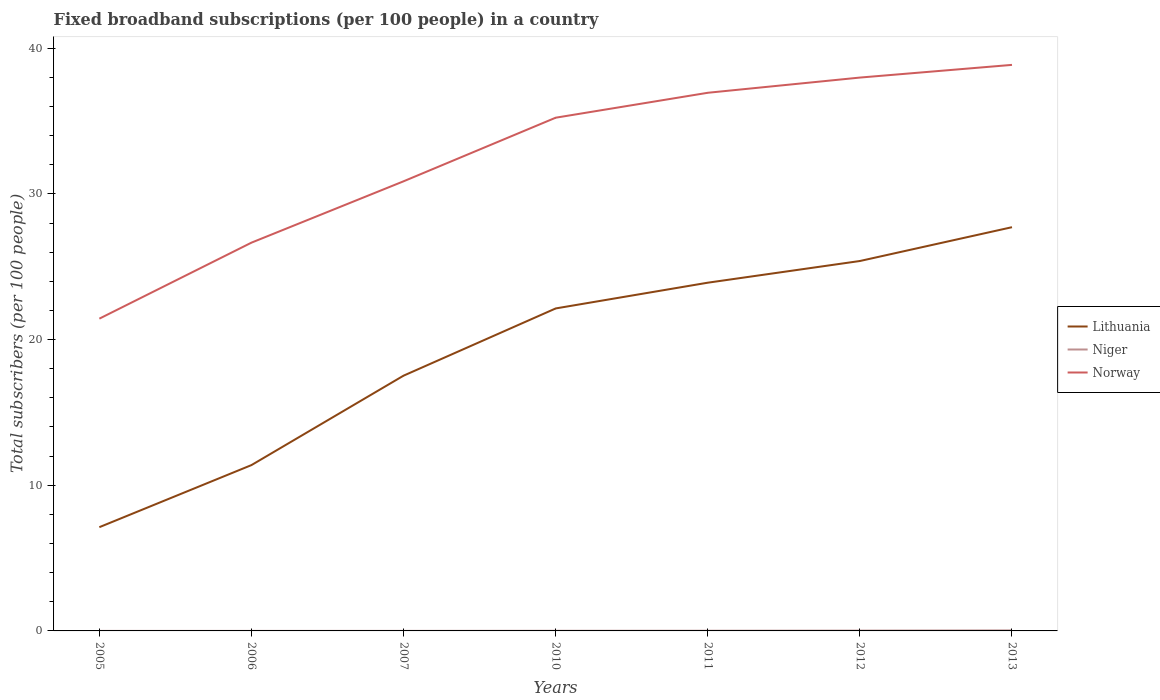Is the number of lines equal to the number of legend labels?
Your response must be concise. Yes. Across all years, what is the maximum number of broadband subscriptions in Niger?
Your response must be concise. 0. What is the total number of broadband subscriptions in Niger in the graph?
Provide a succinct answer. -0.01. What is the difference between the highest and the second highest number of broadband subscriptions in Niger?
Your answer should be very brief. 0.03. How many legend labels are there?
Provide a succinct answer. 3. What is the title of the graph?
Provide a succinct answer. Fixed broadband subscriptions (per 100 people) in a country. Does "Panama" appear as one of the legend labels in the graph?
Make the answer very short. No. What is the label or title of the Y-axis?
Keep it short and to the point. Total subscribers (per 100 people). What is the Total subscribers (per 100 people) of Lithuania in 2005?
Keep it short and to the point. 7.12. What is the Total subscribers (per 100 people) of Niger in 2005?
Offer a terse response. 0. What is the Total subscribers (per 100 people) of Norway in 2005?
Your answer should be very brief. 21.44. What is the Total subscribers (per 100 people) in Lithuania in 2006?
Your answer should be compact. 11.38. What is the Total subscribers (per 100 people) in Niger in 2006?
Your answer should be very brief. 0. What is the Total subscribers (per 100 people) in Norway in 2006?
Offer a terse response. 26.66. What is the Total subscribers (per 100 people) of Lithuania in 2007?
Offer a terse response. 17.52. What is the Total subscribers (per 100 people) in Niger in 2007?
Provide a short and direct response. 0. What is the Total subscribers (per 100 people) of Norway in 2007?
Ensure brevity in your answer.  30.87. What is the Total subscribers (per 100 people) in Lithuania in 2010?
Ensure brevity in your answer.  22.14. What is the Total subscribers (per 100 people) of Niger in 2010?
Offer a very short reply. 0.01. What is the Total subscribers (per 100 people) in Norway in 2010?
Your answer should be compact. 35.23. What is the Total subscribers (per 100 people) of Lithuania in 2011?
Your answer should be very brief. 23.91. What is the Total subscribers (per 100 people) in Niger in 2011?
Offer a terse response. 0.01. What is the Total subscribers (per 100 people) of Norway in 2011?
Your answer should be compact. 36.94. What is the Total subscribers (per 100 people) in Lithuania in 2012?
Provide a succinct answer. 25.39. What is the Total subscribers (per 100 people) of Niger in 2012?
Your response must be concise. 0.02. What is the Total subscribers (per 100 people) in Norway in 2012?
Give a very brief answer. 37.99. What is the Total subscribers (per 100 people) of Lithuania in 2013?
Your response must be concise. 27.72. What is the Total subscribers (per 100 people) in Niger in 2013?
Keep it short and to the point. 0.04. What is the Total subscribers (per 100 people) in Norway in 2013?
Your answer should be very brief. 38.86. Across all years, what is the maximum Total subscribers (per 100 people) of Lithuania?
Make the answer very short. 27.72. Across all years, what is the maximum Total subscribers (per 100 people) in Niger?
Provide a succinct answer. 0.04. Across all years, what is the maximum Total subscribers (per 100 people) of Norway?
Provide a short and direct response. 38.86. Across all years, what is the minimum Total subscribers (per 100 people) of Lithuania?
Keep it short and to the point. 7.12. Across all years, what is the minimum Total subscribers (per 100 people) of Niger?
Your answer should be very brief. 0. Across all years, what is the minimum Total subscribers (per 100 people) of Norway?
Provide a short and direct response. 21.44. What is the total Total subscribers (per 100 people) in Lithuania in the graph?
Ensure brevity in your answer.  135.19. What is the total Total subscribers (per 100 people) of Niger in the graph?
Your answer should be compact. 0.09. What is the total Total subscribers (per 100 people) in Norway in the graph?
Keep it short and to the point. 227.99. What is the difference between the Total subscribers (per 100 people) of Lithuania in 2005 and that in 2006?
Make the answer very short. -4.26. What is the difference between the Total subscribers (per 100 people) in Niger in 2005 and that in 2006?
Your answer should be very brief. -0. What is the difference between the Total subscribers (per 100 people) in Norway in 2005 and that in 2006?
Ensure brevity in your answer.  -5.22. What is the difference between the Total subscribers (per 100 people) of Lithuania in 2005 and that in 2007?
Give a very brief answer. -10.4. What is the difference between the Total subscribers (per 100 people) of Niger in 2005 and that in 2007?
Ensure brevity in your answer.  -0. What is the difference between the Total subscribers (per 100 people) of Norway in 2005 and that in 2007?
Make the answer very short. -9.43. What is the difference between the Total subscribers (per 100 people) of Lithuania in 2005 and that in 2010?
Give a very brief answer. -15.02. What is the difference between the Total subscribers (per 100 people) in Niger in 2005 and that in 2010?
Offer a very short reply. -0.01. What is the difference between the Total subscribers (per 100 people) of Norway in 2005 and that in 2010?
Your answer should be very brief. -13.8. What is the difference between the Total subscribers (per 100 people) in Lithuania in 2005 and that in 2011?
Provide a short and direct response. -16.78. What is the difference between the Total subscribers (per 100 people) in Niger in 2005 and that in 2011?
Your answer should be compact. -0.01. What is the difference between the Total subscribers (per 100 people) in Norway in 2005 and that in 2011?
Offer a terse response. -15.51. What is the difference between the Total subscribers (per 100 people) of Lithuania in 2005 and that in 2012?
Provide a succinct answer. -18.27. What is the difference between the Total subscribers (per 100 people) of Niger in 2005 and that in 2012?
Your answer should be compact. -0.02. What is the difference between the Total subscribers (per 100 people) of Norway in 2005 and that in 2012?
Ensure brevity in your answer.  -16.55. What is the difference between the Total subscribers (per 100 people) in Lithuania in 2005 and that in 2013?
Provide a succinct answer. -20.59. What is the difference between the Total subscribers (per 100 people) in Niger in 2005 and that in 2013?
Make the answer very short. -0.03. What is the difference between the Total subscribers (per 100 people) of Norway in 2005 and that in 2013?
Provide a succinct answer. -17.42. What is the difference between the Total subscribers (per 100 people) in Lithuania in 2006 and that in 2007?
Give a very brief answer. -6.14. What is the difference between the Total subscribers (per 100 people) of Niger in 2006 and that in 2007?
Provide a short and direct response. -0. What is the difference between the Total subscribers (per 100 people) of Norway in 2006 and that in 2007?
Give a very brief answer. -4.21. What is the difference between the Total subscribers (per 100 people) in Lithuania in 2006 and that in 2010?
Give a very brief answer. -10.75. What is the difference between the Total subscribers (per 100 people) in Niger in 2006 and that in 2010?
Offer a terse response. -0.01. What is the difference between the Total subscribers (per 100 people) of Norway in 2006 and that in 2010?
Your answer should be very brief. -8.58. What is the difference between the Total subscribers (per 100 people) of Lithuania in 2006 and that in 2011?
Provide a succinct answer. -12.52. What is the difference between the Total subscribers (per 100 people) in Niger in 2006 and that in 2011?
Your answer should be compact. -0.01. What is the difference between the Total subscribers (per 100 people) of Norway in 2006 and that in 2011?
Provide a short and direct response. -10.29. What is the difference between the Total subscribers (per 100 people) in Lithuania in 2006 and that in 2012?
Give a very brief answer. -14.01. What is the difference between the Total subscribers (per 100 people) in Niger in 2006 and that in 2012?
Keep it short and to the point. -0.02. What is the difference between the Total subscribers (per 100 people) of Norway in 2006 and that in 2012?
Provide a short and direct response. -11.33. What is the difference between the Total subscribers (per 100 people) of Lithuania in 2006 and that in 2013?
Your response must be concise. -16.33. What is the difference between the Total subscribers (per 100 people) in Niger in 2006 and that in 2013?
Provide a short and direct response. -0.03. What is the difference between the Total subscribers (per 100 people) in Norway in 2006 and that in 2013?
Your answer should be very brief. -12.2. What is the difference between the Total subscribers (per 100 people) in Lithuania in 2007 and that in 2010?
Provide a short and direct response. -4.61. What is the difference between the Total subscribers (per 100 people) in Niger in 2007 and that in 2010?
Provide a succinct answer. -0.01. What is the difference between the Total subscribers (per 100 people) of Norway in 2007 and that in 2010?
Ensure brevity in your answer.  -4.37. What is the difference between the Total subscribers (per 100 people) of Lithuania in 2007 and that in 2011?
Provide a short and direct response. -6.38. What is the difference between the Total subscribers (per 100 people) of Niger in 2007 and that in 2011?
Make the answer very short. -0.01. What is the difference between the Total subscribers (per 100 people) of Norway in 2007 and that in 2011?
Offer a terse response. -6.08. What is the difference between the Total subscribers (per 100 people) in Lithuania in 2007 and that in 2012?
Make the answer very short. -7.87. What is the difference between the Total subscribers (per 100 people) in Niger in 2007 and that in 2012?
Provide a succinct answer. -0.02. What is the difference between the Total subscribers (per 100 people) in Norway in 2007 and that in 2012?
Offer a very short reply. -7.12. What is the difference between the Total subscribers (per 100 people) in Lithuania in 2007 and that in 2013?
Keep it short and to the point. -10.19. What is the difference between the Total subscribers (per 100 people) in Niger in 2007 and that in 2013?
Your answer should be compact. -0.03. What is the difference between the Total subscribers (per 100 people) of Norway in 2007 and that in 2013?
Ensure brevity in your answer.  -7.99. What is the difference between the Total subscribers (per 100 people) of Lithuania in 2010 and that in 2011?
Keep it short and to the point. -1.77. What is the difference between the Total subscribers (per 100 people) in Niger in 2010 and that in 2011?
Keep it short and to the point. -0. What is the difference between the Total subscribers (per 100 people) in Norway in 2010 and that in 2011?
Your answer should be very brief. -1.71. What is the difference between the Total subscribers (per 100 people) in Lithuania in 2010 and that in 2012?
Offer a terse response. -3.26. What is the difference between the Total subscribers (per 100 people) in Niger in 2010 and that in 2012?
Keep it short and to the point. -0.01. What is the difference between the Total subscribers (per 100 people) in Norway in 2010 and that in 2012?
Provide a short and direct response. -2.75. What is the difference between the Total subscribers (per 100 people) in Lithuania in 2010 and that in 2013?
Your answer should be compact. -5.58. What is the difference between the Total subscribers (per 100 people) of Niger in 2010 and that in 2013?
Offer a very short reply. -0.03. What is the difference between the Total subscribers (per 100 people) of Norway in 2010 and that in 2013?
Your answer should be compact. -3.63. What is the difference between the Total subscribers (per 100 people) in Lithuania in 2011 and that in 2012?
Your response must be concise. -1.49. What is the difference between the Total subscribers (per 100 people) in Niger in 2011 and that in 2012?
Offer a very short reply. -0.01. What is the difference between the Total subscribers (per 100 people) of Norway in 2011 and that in 2012?
Your response must be concise. -1.04. What is the difference between the Total subscribers (per 100 people) of Lithuania in 2011 and that in 2013?
Provide a succinct answer. -3.81. What is the difference between the Total subscribers (per 100 people) in Niger in 2011 and that in 2013?
Your answer should be compact. -0.02. What is the difference between the Total subscribers (per 100 people) in Norway in 2011 and that in 2013?
Offer a terse response. -1.92. What is the difference between the Total subscribers (per 100 people) of Lithuania in 2012 and that in 2013?
Your answer should be very brief. -2.32. What is the difference between the Total subscribers (per 100 people) in Niger in 2012 and that in 2013?
Provide a short and direct response. -0.01. What is the difference between the Total subscribers (per 100 people) of Norway in 2012 and that in 2013?
Give a very brief answer. -0.87. What is the difference between the Total subscribers (per 100 people) in Lithuania in 2005 and the Total subscribers (per 100 people) in Niger in 2006?
Your answer should be very brief. 7.12. What is the difference between the Total subscribers (per 100 people) of Lithuania in 2005 and the Total subscribers (per 100 people) of Norway in 2006?
Provide a short and direct response. -19.53. What is the difference between the Total subscribers (per 100 people) in Niger in 2005 and the Total subscribers (per 100 people) in Norway in 2006?
Ensure brevity in your answer.  -26.65. What is the difference between the Total subscribers (per 100 people) of Lithuania in 2005 and the Total subscribers (per 100 people) of Niger in 2007?
Offer a terse response. 7.12. What is the difference between the Total subscribers (per 100 people) of Lithuania in 2005 and the Total subscribers (per 100 people) of Norway in 2007?
Offer a very short reply. -23.75. What is the difference between the Total subscribers (per 100 people) of Niger in 2005 and the Total subscribers (per 100 people) of Norway in 2007?
Provide a succinct answer. -30.87. What is the difference between the Total subscribers (per 100 people) of Lithuania in 2005 and the Total subscribers (per 100 people) of Niger in 2010?
Offer a very short reply. 7.11. What is the difference between the Total subscribers (per 100 people) in Lithuania in 2005 and the Total subscribers (per 100 people) in Norway in 2010?
Give a very brief answer. -28.11. What is the difference between the Total subscribers (per 100 people) in Niger in 2005 and the Total subscribers (per 100 people) in Norway in 2010?
Make the answer very short. -35.23. What is the difference between the Total subscribers (per 100 people) in Lithuania in 2005 and the Total subscribers (per 100 people) in Niger in 2011?
Offer a terse response. 7.11. What is the difference between the Total subscribers (per 100 people) in Lithuania in 2005 and the Total subscribers (per 100 people) in Norway in 2011?
Your answer should be compact. -29.82. What is the difference between the Total subscribers (per 100 people) in Niger in 2005 and the Total subscribers (per 100 people) in Norway in 2011?
Give a very brief answer. -36.94. What is the difference between the Total subscribers (per 100 people) of Lithuania in 2005 and the Total subscribers (per 100 people) of Niger in 2012?
Your answer should be very brief. 7.1. What is the difference between the Total subscribers (per 100 people) of Lithuania in 2005 and the Total subscribers (per 100 people) of Norway in 2012?
Offer a very short reply. -30.87. What is the difference between the Total subscribers (per 100 people) of Niger in 2005 and the Total subscribers (per 100 people) of Norway in 2012?
Ensure brevity in your answer.  -37.99. What is the difference between the Total subscribers (per 100 people) in Lithuania in 2005 and the Total subscribers (per 100 people) in Niger in 2013?
Provide a short and direct response. 7.09. What is the difference between the Total subscribers (per 100 people) in Lithuania in 2005 and the Total subscribers (per 100 people) in Norway in 2013?
Your response must be concise. -31.74. What is the difference between the Total subscribers (per 100 people) of Niger in 2005 and the Total subscribers (per 100 people) of Norway in 2013?
Make the answer very short. -38.86. What is the difference between the Total subscribers (per 100 people) in Lithuania in 2006 and the Total subscribers (per 100 people) in Niger in 2007?
Give a very brief answer. 11.38. What is the difference between the Total subscribers (per 100 people) in Lithuania in 2006 and the Total subscribers (per 100 people) in Norway in 2007?
Make the answer very short. -19.48. What is the difference between the Total subscribers (per 100 people) in Niger in 2006 and the Total subscribers (per 100 people) in Norway in 2007?
Give a very brief answer. -30.86. What is the difference between the Total subscribers (per 100 people) of Lithuania in 2006 and the Total subscribers (per 100 people) of Niger in 2010?
Provide a short and direct response. 11.37. What is the difference between the Total subscribers (per 100 people) in Lithuania in 2006 and the Total subscribers (per 100 people) in Norway in 2010?
Provide a succinct answer. -23.85. What is the difference between the Total subscribers (per 100 people) of Niger in 2006 and the Total subscribers (per 100 people) of Norway in 2010?
Your response must be concise. -35.23. What is the difference between the Total subscribers (per 100 people) of Lithuania in 2006 and the Total subscribers (per 100 people) of Niger in 2011?
Provide a short and direct response. 11.37. What is the difference between the Total subscribers (per 100 people) in Lithuania in 2006 and the Total subscribers (per 100 people) in Norway in 2011?
Ensure brevity in your answer.  -25.56. What is the difference between the Total subscribers (per 100 people) of Niger in 2006 and the Total subscribers (per 100 people) of Norway in 2011?
Offer a very short reply. -36.94. What is the difference between the Total subscribers (per 100 people) of Lithuania in 2006 and the Total subscribers (per 100 people) of Niger in 2012?
Provide a succinct answer. 11.36. What is the difference between the Total subscribers (per 100 people) in Lithuania in 2006 and the Total subscribers (per 100 people) in Norway in 2012?
Your answer should be compact. -26.6. What is the difference between the Total subscribers (per 100 people) in Niger in 2006 and the Total subscribers (per 100 people) in Norway in 2012?
Give a very brief answer. -37.99. What is the difference between the Total subscribers (per 100 people) of Lithuania in 2006 and the Total subscribers (per 100 people) of Niger in 2013?
Offer a very short reply. 11.35. What is the difference between the Total subscribers (per 100 people) in Lithuania in 2006 and the Total subscribers (per 100 people) in Norway in 2013?
Offer a very short reply. -27.48. What is the difference between the Total subscribers (per 100 people) in Niger in 2006 and the Total subscribers (per 100 people) in Norway in 2013?
Offer a terse response. -38.86. What is the difference between the Total subscribers (per 100 people) of Lithuania in 2007 and the Total subscribers (per 100 people) of Niger in 2010?
Your answer should be very brief. 17.51. What is the difference between the Total subscribers (per 100 people) in Lithuania in 2007 and the Total subscribers (per 100 people) in Norway in 2010?
Ensure brevity in your answer.  -17.71. What is the difference between the Total subscribers (per 100 people) of Niger in 2007 and the Total subscribers (per 100 people) of Norway in 2010?
Offer a terse response. -35.23. What is the difference between the Total subscribers (per 100 people) in Lithuania in 2007 and the Total subscribers (per 100 people) in Niger in 2011?
Provide a succinct answer. 17.51. What is the difference between the Total subscribers (per 100 people) of Lithuania in 2007 and the Total subscribers (per 100 people) of Norway in 2011?
Make the answer very short. -19.42. What is the difference between the Total subscribers (per 100 people) in Niger in 2007 and the Total subscribers (per 100 people) in Norway in 2011?
Offer a terse response. -36.94. What is the difference between the Total subscribers (per 100 people) of Lithuania in 2007 and the Total subscribers (per 100 people) of Niger in 2012?
Provide a succinct answer. 17.5. What is the difference between the Total subscribers (per 100 people) in Lithuania in 2007 and the Total subscribers (per 100 people) in Norway in 2012?
Ensure brevity in your answer.  -20.46. What is the difference between the Total subscribers (per 100 people) in Niger in 2007 and the Total subscribers (per 100 people) in Norway in 2012?
Make the answer very short. -37.99. What is the difference between the Total subscribers (per 100 people) in Lithuania in 2007 and the Total subscribers (per 100 people) in Niger in 2013?
Your answer should be compact. 17.49. What is the difference between the Total subscribers (per 100 people) in Lithuania in 2007 and the Total subscribers (per 100 people) in Norway in 2013?
Give a very brief answer. -21.34. What is the difference between the Total subscribers (per 100 people) in Niger in 2007 and the Total subscribers (per 100 people) in Norway in 2013?
Provide a succinct answer. -38.86. What is the difference between the Total subscribers (per 100 people) in Lithuania in 2010 and the Total subscribers (per 100 people) in Niger in 2011?
Keep it short and to the point. 22.13. What is the difference between the Total subscribers (per 100 people) of Lithuania in 2010 and the Total subscribers (per 100 people) of Norway in 2011?
Provide a short and direct response. -14.81. What is the difference between the Total subscribers (per 100 people) of Niger in 2010 and the Total subscribers (per 100 people) of Norway in 2011?
Provide a succinct answer. -36.94. What is the difference between the Total subscribers (per 100 people) in Lithuania in 2010 and the Total subscribers (per 100 people) in Niger in 2012?
Offer a very short reply. 22.12. What is the difference between the Total subscribers (per 100 people) of Lithuania in 2010 and the Total subscribers (per 100 people) of Norway in 2012?
Keep it short and to the point. -15.85. What is the difference between the Total subscribers (per 100 people) of Niger in 2010 and the Total subscribers (per 100 people) of Norway in 2012?
Keep it short and to the point. -37.98. What is the difference between the Total subscribers (per 100 people) in Lithuania in 2010 and the Total subscribers (per 100 people) in Niger in 2013?
Provide a short and direct response. 22.1. What is the difference between the Total subscribers (per 100 people) in Lithuania in 2010 and the Total subscribers (per 100 people) in Norway in 2013?
Your answer should be very brief. -16.72. What is the difference between the Total subscribers (per 100 people) in Niger in 2010 and the Total subscribers (per 100 people) in Norway in 2013?
Offer a very short reply. -38.85. What is the difference between the Total subscribers (per 100 people) of Lithuania in 2011 and the Total subscribers (per 100 people) of Niger in 2012?
Give a very brief answer. 23.88. What is the difference between the Total subscribers (per 100 people) in Lithuania in 2011 and the Total subscribers (per 100 people) in Norway in 2012?
Your answer should be compact. -14.08. What is the difference between the Total subscribers (per 100 people) in Niger in 2011 and the Total subscribers (per 100 people) in Norway in 2012?
Offer a terse response. -37.98. What is the difference between the Total subscribers (per 100 people) of Lithuania in 2011 and the Total subscribers (per 100 people) of Niger in 2013?
Offer a very short reply. 23.87. What is the difference between the Total subscribers (per 100 people) in Lithuania in 2011 and the Total subscribers (per 100 people) in Norway in 2013?
Ensure brevity in your answer.  -14.95. What is the difference between the Total subscribers (per 100 people) in Niger in 2011 and the Total subscribers (per 100 people) in Norway in 2013?
Offer a very short reply. -38.85. What is the difference between the Total subscribers (per 100 people) in Lithuania in 2012 and the Total subscribers (per 100 people) in Niger in 2013?
Ensure brevity in your answer.  25.36. What is the difference between the Total subscribers (per 100 people) in Lithuania in 2012 and the Total subscribers (per 100 people) in Norway in 2013?
Give a very brief answer. -13.46. What is the difference between the Total subscribers (per 100 people) of Niger in 2012 and the Total subscribers (per 100 people) of Norway in 2013?
Make the answer very short. -38.84. What is the average Total subscribers (per 100 people) in Lithuania per year?
Your response must be concise. 19.31. What is the average Total subscribers (per 100 people) in Niger per year?
Ensure brevity in your answer.  0.01. What is the average Total subscribers (per 100 people) of Norway per year?
Your answer should be very brief. 32.57. In the year 2005, what is the difference between the Total subscribers (per 100 people) of Lithuania and Total subscribers (per 100 people) of Niger?
Your answer should be very brief. 7.12. In the year 2005, what is the difference between the Total subscribers (per 100 people) of Lithuania and Total subscribers (per 100 people) of Norway?
Ensure brevity in your answer.  -14.32. In the year 2005, what is the difference between the Total subscribers (per 100 people) in Niger and Total subscribers (per 100 people) in Norway?
Offer a terse response. -21.44. In the year 2006, what is the difference between the Total subscribers (per 100 people) in Lithuania and Total subscribers (per 100 people) in Niger?
Your answer should be compact. 11.38. In the year 2006, what is the difference between the Total subscribers (per 100 people) in Lithuania and Total subscribers (per 100 people) in Norway?
Your response must be concise. -15.27. In the year 2006, what is the difference between the Total subscribers (per 100 people) in Niger and Total subscribers (per 100 people) in Norway?
Give a very brief answer. -26.65. In the year 2007, what is the difference between the Total subscribers (per 100 people) of Lithuania and Total subscribers (per 100 people) of Niger?
Keep it short and to the point. 17.52. In the year 2007, what is the difference between the Total subscribers (per 100 people) of Lithuania and Total subscribers (per 100 people) of Norway?
Your answer should be very brief. -13.34. In the year 2007, what is the difference between the Total subscribers (per 100 people) in Niger and Total subscribers (per 100 people) in Norway?
Offer a very short reply. -30.86. In the year 2010, what is the difference between the Total subscribers (per 100 people) in Lithuania and Total subscribers (per 100 people) in Niger?
Ensure brevity in your answer.  22.13. In the year 2010, what is the difference between the Total subscribers (per 100 people) in Lithuania and Total subscribers (per 100 people) in Norway?
Make the answer very short. -13.09. In the year 2010, what is the difference between the Total subscribers (per 100 people) in Niger and Total subscribers (per 100 people) in Norway?
Offer a terse response. -35.22. In the year 2011, what is the difference between the Total subscribers (per 100 people) in Lithuania and Total subscribers (per 100 people) in Niger?
Provide a short and direct response. 23.89. In the year 2011, what is the difference between the Total subscribers (per 100 people) in Lithuania and Total subscribers (per 100 people) in Norway?
Your answer should be compact. -13.04. In the year 2011, what is the difference between the Total subscribers (per 100 people) in Niger and Total subscribers (per 100 people) in Norway?
Provide a succinct answer. -36.93. In the year 2012, what is the difference between the Total subscribers (per 100 people) of Lithuania and Total subscribers (per 100 people) of Niger?
Offer a terse response. 25.37. In the year 2012, what is the difference between the Total subscribers (per 100 people) in Lithuania and Total subscribers (per 100 people) in Norway?
Keep it short and to the point. -12.59. In the year 2012, what is the difference between the Total subscribers (per 100 people) in Niger and Total subscribers (per 100 people) in Norway?
Your response must be concise. -37.97. In the year 2013, what is the difference between the Total subscribers (per 100 people) of Lithuania and Total subscribers (per 100 people) of Niger?
Your answer should be very brief. 27.68. In the year 2013, what is the difference between the Total subscribers (per 100 people) in Lithuania and Total subscribers (per 100 people) in Norway?
Your answer should be very brief. -11.14. In the year 2013, what is the difference between the Total subscribers (per 100 people) in Niger and Total subscribers (per 100 people) in Norway?
Offer a terse response. -38.82. What is the ratio of the Total subscribers (per 100 people) of Lithuania in 2005 to that in 2006?
Keep it short and to the point. 0.63. What is the ratio of the Total subscribers (per 100 people) of Niger in 2005 to that in 2006?
Your response must be concise. 0.63. What is the ratio of the Total subscribers (per 100 people) of Norway in 2005 to that in 2006?
Provide a short and direct response. 0.8. What is the ratio of the Total subscribers (per 100 people) in Lithuania in 2005 to that in 2007?
Your response must be concise. 0.41. What is the ratio of the Total subscribers (per 100 people) of Niger in 2005 to that in 2007?
Provide a short and direct response. 0.47. What is the ratio of the Total subscribers (per 100 people) in Norway in 2005 to that in 2007?
Make the answer very short. 0.69. What is the ratio of the Total subscribers (per 100 people) in Lithuania in 2005 to that in 2010?
Your response must be concise. 0.32. What is the ratio of the Total subscribers (per 100 people) in Niger in 2005 to that in 2010?
Your answer should be very brief. 0.17. What is the ratio of the Total subscribers (per 100 people) in Norway in 2005 to that in 2010?
Make the answer very short. 0.61. What is the ratio of the Total subscribers (per 100 people) in Lithuania in 2005 to that in 2011?
Keep it short and to the point. 0.3. What is the ratio of the Total subscribers (per 100 people) of Niger in 2005 to that in 2011?
Offer a very short reply. 0.13. What is the ratio of the Total subscribers (per 100 people) of Norway in 2005 to that in 2011?
Keep it short and to the point. 0.58. What is the ratio of the Total subscribers (per 100 people) in Lithuania in 2005 to that in 2012?
Provide a succinct answer. 0.28. What is the ratio of the Total subscribers (per 100 people) in Niger in 2005 to that in 2012?
Your answer should be very brief. 0.08. What is the ratio of the Total subscribers (per 100 people) of Norway in 2005 to that in 2012?
Keep it short and to the point. 0.56. What is the ratio of the Total subscribers (per 100 people) of Lithuania in 2005 to that in 2013?
Your answer should be compact. 0.26. What is the ratio of the Total subscribers (per 100 people) in Niger in 2005 to that in 2013?
Ensure brevity in your answer.  0.04. What is the ratio of the Total subscribers (per 100 people) in Norway in 2005 to that in 2013?
Your answer should be very brief. 0.55. What is the ratio of the Total subscribers (per 100 people) in Lithuania in 2006 to that in 2007?
Give a very brief answer. 0.65. What is the ratio of the Total subscribers (per 100 people) of Niger in 2006 to that in 2007?
Your answer should be very brief. 0.75. What is the ratio of the Total subscribers (per 100 people) in Norway in 2006 to that in 2007?
Your response must be concise. 0.86. What is the ratio of the Total subscribers (per 100 people) in Lithuania in 2006 to that in 2010?
Offer a terse response. 0.51. What is the ratio of the Total subscribers (per 100 people) in Niger in 2006 to that in 2010?
Provide a short and direct response. 0.27. What is the ratio of the Total subscribers (per 100 people) of Norway in 2006 to that in 2010?
Provide a succinct answer. 0.76. What is the ratio of the Total subscribers (per 100 people) of Lithuania in 2006 to that in 2011?
Give a very brief answer. 0.48. What is the ratio of the Total subscribers (per 100 people) in Niger in 2006 to that in 2011?
Your answer should be very brief. 0.2. What is the ratio of the Total subscribers (per 100 people) in Norway in 2006 to that in 2011?
Give a very brief answer. 0.72. What is the ratio of the Total subscribers (per 100 people) of Lithuania in 2006 to that in 2012?
Make the answer very short. 0.45. What is the ratio of the Total subscribers (per 100 people) in Niger in 2006 to that in 2012?
Offer a very short reply. 0.12. What is the ratio of the Total subscribers (per 100 people) in Norway in 2006 to that in 2012?
Offer a terse response. 0.7. What is the ratio of the Total subscribers (per 100 people) of Lithuania in 2006 to that in 2013?
Offer a very short reply. 0.41. What is the ratio of the Total subscribers (per 100 people) of Niger in 2006 to that in 2013?
Provide a short and direct response. 0.07. What is the ratio of the Total subscribers (per 100 people) in Norway in 2006 to that in 2013?
Provide a succinct answer. 0.69. What is the ratio of the Total subscribers (per 100 people) of Lithuania in 2007 to that in 2010?
Make the answer very short. 0.79. What is the ratio of the Total subscribers (per 100 people) in Niger in 2007 to that in 2010?
Your answer should be very brief. 0.36. What is the ratio of the Total subscribers (per 100 people) of Norway in 2007 to that in 2010?
Provide a short and direct response. 0.88. What is the ratio of the Total subscribers (per 100 people) of Lithuania in 2007 to that in 2011?
Your answer should be very brief. 0.73. What is the ratio of the Total subscribers (per 100 people) in Niger in 2007 to that in 2011?
Ensure brevity in your answer.  0.27. What is the ratio of the Total subscribers (per 100 people) of Norway in 2007 to that in 2011?
Offer a very short reply. 0.84. What is the ratio of the Total subscribers (per 100 people) in Lithuania in 2007 to that in 2012?
Offer a terse response. 0.69. What is the ratio of the Total subscribers (per 100 people) of Niger in 2007 to that in 2012?
Offer a very short reply. 0.16. What is the ratio of the Total subscribers (per 100 people) in Norway in 2007 to that in 2012?
Your answer should be compact. 0.81. What is the ratio of the Total subscribers (per 100 people) of Lithuania in 2007 to that in 2013?
Provide a short and direct response. 0.63. What is the ratio of the Total subscribers (per 100 people) of Niger in 2007 to that in 2013?
Make the answer very short. 0.09. What is the ratio of the Total subscribers (per 100 people) of Norway in 2007 to that in 2013?
Offer a terse response. 0.79. What is the ratio of the Total subscribers (per 100 people) of Lithuania in 2010 to that in 2011?
Make the answer very short. 0.93. What is the ratio of the Total subscribers (per 100 people) of Niger in 2010 to that in 2011?
Provide a short and direct response. 0.74. What is the ratio of the Total subscribers (per 100 people) of Norway in 2010 to that in 2011?
Offer a very short reply. 0.95. What is the ratio of the Total subscribers (per 100 people) in Lithuania in 2010 to that in 2012?
Give a very brief answer. 0.87. What is the ratio of the Total subscribers (per 100 people) of Niger in 2010 to that in 2012?
Provide a short and direct response. 0.44. What is the ratio of the Total subscribers (per 100 people) in Norway in 2010 to that in 2012?
Offer a very short reply. 0.93. What is the ratio of the Total subscribers (per 100 people) in Lithuania in 2010 to that in 2013?
Give a very brief answer. 0.8. What is the ratio of the Total subscribers (per 100 people) in Niger in 2010 to that in 2013?
Keep it short and to the point. 0.26. What is the ratio of the Total subscribers (per 100 people) of Norway in 2010 to that in 2013?
Your answer should be very brief. 0.91. What is the ratio of the Total subscribers (per 100 people) in Lithuania in 2011 to that in 2012?
Provide a succinct answer. 0.94. What is the ratio of the Total subscribers (per 100 people) in Niger in 2011 to that in 2012?
Keep it short and to the point. 0.6. What is the ratio of the Total subscribers (per 100 people) of Norway in 2011 to that in 2012?
Offer a terse response. 0.97. What is the ratio of the Total subscribers (per 100 people) of Lithuania in 2011 to that in 2013?
Your response must be concise. 0.86. What is the ratio of the Total subscribers (per 100 people) in Niger in 2011 to that in 2013?
Offer a very short reply. 0.36. What is the ratio of the Total subscribers (per 100 people) of Norway in 2011 to that in 2013?
Offer a very short reply. 0.95. What is the ratio of the Total subscribers (per 100 people) in Lithuania in 2012 to that in 2013?
Give a very brief answer. 0.92. What is the ratio of the Total subscribers (per 100 people) in Niger in 2012 to that in 2013?
Give a very brief answer. 0.6. What is the ratio of the Total subscribers (per 100 people) in Norway in 2012 to that in 2013?
Provide a succinct answer. 0.98. What is the difference between the highest and the second highest Total subscribers (per 100 people) of Lithuania?
Your response must be concise. 2.32. What is the difference between the highest and the second highest Total subscribers (per 100 people) in Niger?
Offer a terse response. 0.01. What is the difference between the highest and the second highest Total subscribers (per 100 people) in Norway?
Your answer should be compact. 0.87. What is the difference between the highest and the lowest Total subscribers (per 100 people) of Lithuania?
Give a very brief answer. 20.59. What is the difference between the highest and the lowest Total subscribers (per 100 people) of Niger?
Ensure brevity in your answer.  0.03. What is the difference between the highest and the lowest Total subscribers (per 100 people) of Norway?
Offer a very short reply. 17.42. 